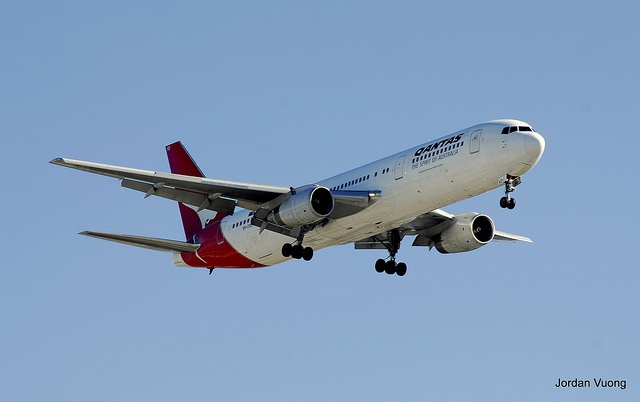Describe the objects in this image and their specific colors. I can see a airplane in darkgray, black, and gray tones in this image. 